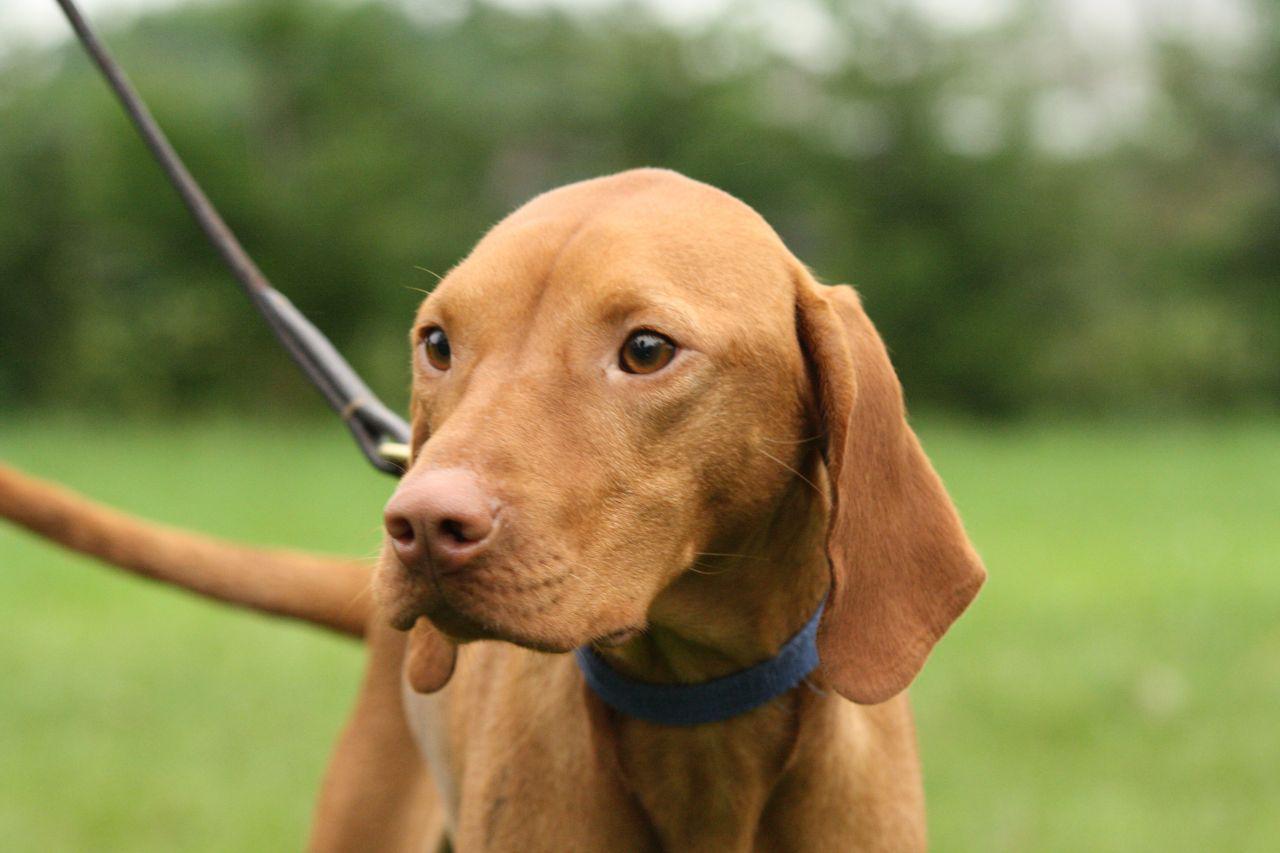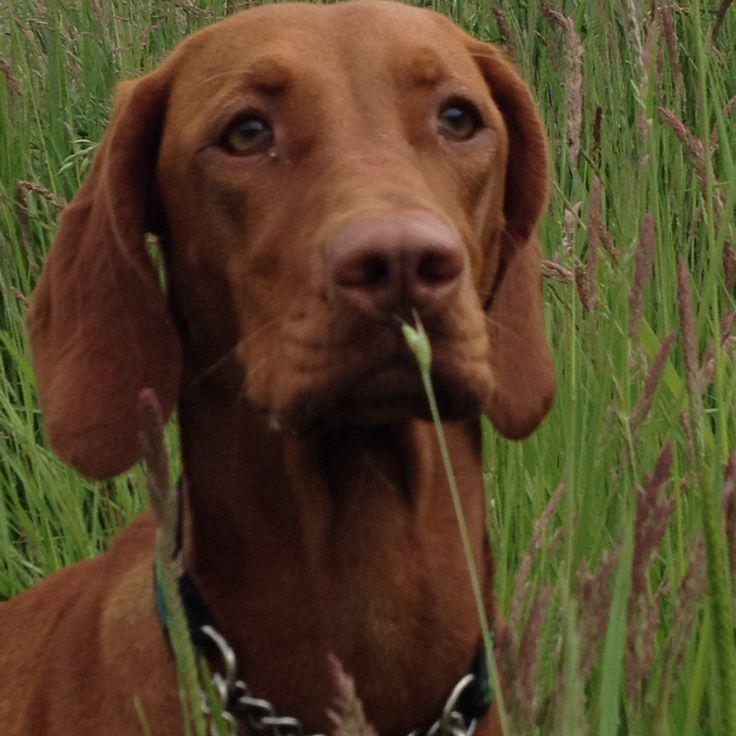The first image is the image on the left, the second image is the image on the right. Assess this claim about the two images: "At least one dog has its mouth open.". Correct or not? Answer yes or no. No. The first image is the image on the left, the second image is the image on the right. Assess this claim about the two images: "The lefthand dog has long floppy ears and is turned slightly leftward, and the righthand dog has its head turned slightly rightward.". Correct or not? Answer yes or no. Yes. 